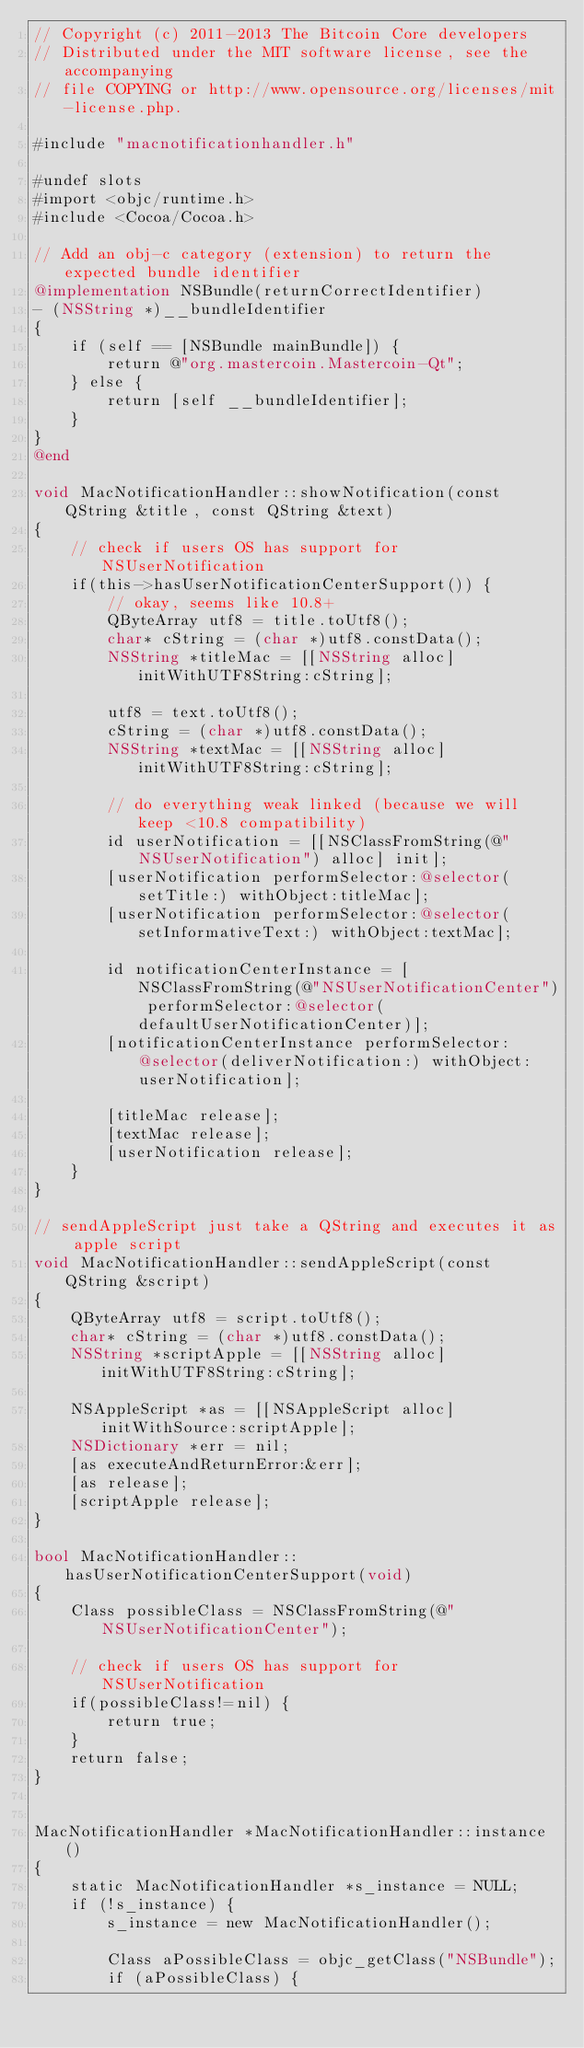Convert code to text. <code><loc_0><loc_0><loc_500><loc_500><_ObjectiveC_>// Copyright (c) 2011-2013 The Bitcoin Core developers
// Distributed under the MIT software license, see the accompanying
// file COPYING or http://www.opensource.org/licenses/mit-license.php.

#include "macnotificationhandler.h"

#undef slots
#import <objc/runtime.h>
#include <Cocoa/Cocoa.h>

// Add an obj-c category (extension) to return the expected bundle identifier
@implementation NSBundle(returnCorrectIdentifier)
- (NSString *)__bundleIdentifier
{
    if (self == [NSBundle mainBundle]) {
        return @"org.mastercoin.Mastercoin-Qt";
    } else {
        return [self __bundleIdentifier];
    }
}
@end

void MacNotificationHandler::showNotification(const QString &title, const QString &text)
{
    // check if users OS has support for NSUserNotification
    if(this->hasUserNotificationCenterSupport()) {
        // okay, seems like 10.8+
        QByteArray utf8 = title.toUtf8();
        char* cString = (char *)utf8.constData();
        NSString *titleMac = [[NSString alloc] initWithUTF8String:cString];

        utf8 = text.toUtf8();
        cString = (char *)utf8.constData();
        NSString *textMac = [[NSString alloc] initWithUTF8String:cString];

        // do everything weak linked (because we will keep <10.8 compatibility)
        id userNotification = [[NSClassFromString(@"NSUserNotification") alloc] init];
        [userNotification performSelector:@selector(setTitle:) withObject:titleMac];
        [userNotification performSelector:@selector(setInformativeText:) withObject:textMac];

        id notificationCenterInstance = [NSClassFromString(@"NSUserNotificationCenter") performSelector:@selector(defaultUserNotificationCenter)];
        [notificationCenterInstance performSelector:@selector(deliverNotification:) withObject:userNotification];

        [titleMac release];
        [textMac release];
        [userNotification release];
    }
}

// sendAppleScript just take a QString and executes it as apple script
void MacNotificationHandler::sendAppleScript(const QString &script)
{
    QByteArray utf8 = script.toUtf8();
    char* cString = (char *)utf8.constData();
    NSString *scriptApple = [[NSString alloc] initWithUTF8String:cString];

    NSAppleScript *as = [[NSAppleScript alloc] initWithSource:scriptApple];
    NSDictionary *err = nil;
    [as executeAndReturnError:&err];
    [as release];
    [scriptApple release];
}

bool MacNotificationHandler::hasUserNotificationCenterSupport(void)
{
    Class possibleClass = NSClassFromString(@"NSUserNotificationCenter");

    // check if users OS has support for NSUserNotification
    if(possibleClass!=nil) {
        return true;
    }
    return false;
}


MacNotificationHandler *MacNotificationHandler::instance()
{
    static MacNotificationHandler *s_instance = NULL;
    if (!s_instance) {
        s_instance = new MacNotificationHandler();
        
        Class aPossibleClass = objc_getClass("NSBundle");
        if (aPossibleClass) {</code> 